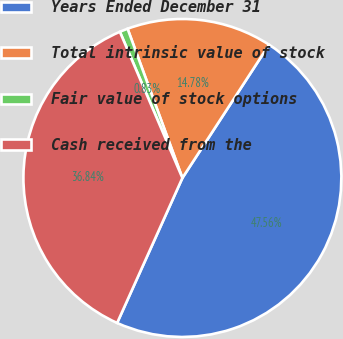<chart> <loc_0><loc_0><loc_500><loc_500><pie_chart><fcel>Years Ended December 31<fcel>Total intrinsic value of stock<fcel>Fair value of stock options<fcel>Cash received from the<nl><fcel>47.56%<fcel>14.78%<fcel>0.83%<fcel>36.84%<nl></chart> 